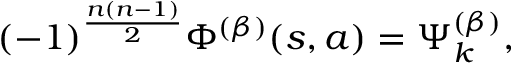Convert formula to latex. <formula><loc_0><loc_0><loc_500><loc_500>( - 1 ) ^ { \frac { n ( n - 1 ) } { 2 } } \Phi ^ { ( \beta ) } ( s , a ) = \Psi _ { k } ^ { ( \beta ) } ,</formula> 